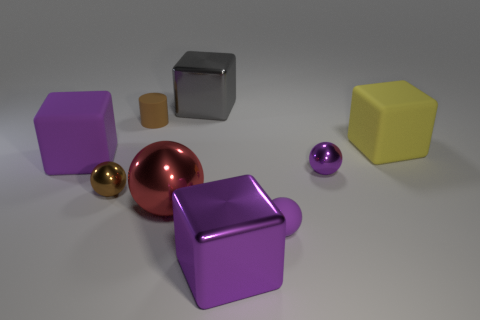Subtract all gray metallic blocks. How many blocks are left? 3 Add 1 gray blocks. How many objects exist? 10 Subtract all gray blocks. How many blocks are left? 3 Subtract all yellow cylinders. Subtract all brown cubes. How many cylinders are left? 1 Subtract all purple cylinders. How many gray balls are left? 0 Subtract all big metal balls. Subtract all big cylinders. How many objects are left? 8 Add 2 brown metal spheres. How many brown metal spheres are left? 3 Add 6 large yellow matte cubes. How many large yellow matte cubes exist? 7 Subtract 1 brown balls. How many objects are left? 8 Subtract all cylinders. How many objects are left? 8 